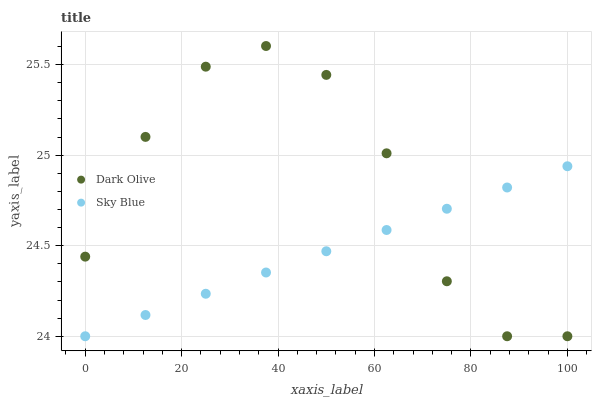Does Sky Blue have the minimum area under the curve?
Answer yes or no. Yes. Does Dark Olive have the maximum area under the curve?
Answer yes or no. Yes. Does Dark Olive have the minimum area under the curve?
Answer yes or no. No. Is Sky Blue the smoothest?
Answer yes or no. Yes. Is Dark Olive the roughest?
Answer yes or no. Yes. Is Dark Olive the smoothest?
Answer yes or no. No. Does Sky Blue have the lowest value?
Answer yes or no. Yes. Does Dark Olive have the highest value?
Answer yes or no. Yes. Does Dark Olive intersect Sky Blue?
Answer yes or no. Yes. Is Dark Olive less than Sky Blue?
Answer yes or no. No. Is Dark Olive greater than Sky Blue?
Answer yes or no. No. 